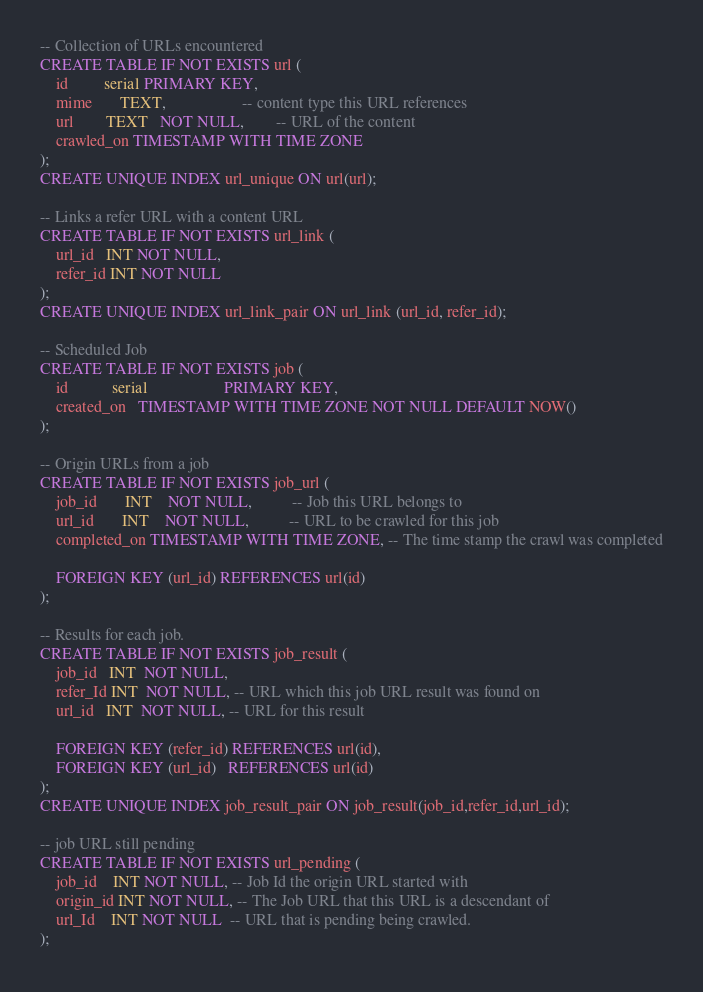Convert code to text. <code><loc_0><loc_0><loc_500><loc_500><_SQL_>
-- Collection of URLs encountered
CREATE TABLE IF NOT EXISTS url (
    id         serial PRIMARY KEY,
    mime       TEXT,                   -- content type this URL references
    url        TEXT   NOT NULL,        -- URL of the content
    crawled_on TIMESTAMP WITH TIME ZONE
);
CREATE UNIQUE INDEX url_unique ON url(url);

-- Links a refer URL with a content URL
CREATE TABLE IF NOT EXISTS url_link (
    url_id   INT NOT NULL,
    refer_id INT NOT NULL
);
CREATE UNIQUE INDEX url_link_pair ON url_link (url_id, refer_id);

-- Scheduled Job
CREATE TABLE IF NOT EXISTS job (
    id           serial                   PRIMARY KEY,
    created_on   TIMESTAMP WITH TIME ZONE NOT NULL DEFAULT NOW()
);

-- Origin URLs from a job
CREATE TABLE IF NOT EXISTS job_url (
    job_id       INT    NOT NULL,          -- Job this URL belongs to
    url_id       INT    NOT NULL,          -- URL to be crawled for this job
    completed_on TIMESTAMP WITH TIME ZONE, -- The time stamp the crawl was completed

    FOREIGN KEY (url_id) REFERENCES url(id)
);

-- Results for each job.
CREATE TABLE IF NOT EXISTS job_result (
    job_id   INT  NOT NULL,
    refer_Id INT  NOT NULL, -- URL which this job URL result was found on
    url_id   INT  NOT NULL, -- URL for this result

    FOREIGN KEY (refer_id) REFERENCES url(id),
    FOREIGN KEY (url_id)   REFERENCES url(id)
);
CREATE UNIQUE INDEX job_result_pair ON job_result(job_id,refer_id,url_id);

-- job URL still pending
CREATE TABLE IF NOT EXISTS url_pending (
    job_id    INT NOT NULL, -- Job Id the origin URL started with
	origin_id INT NOT NULL, -- The Job URL that this URL is a descendant of 
	url_Id    INT NOT NULL  -- URL that is pending being crawled.
);
</code> 